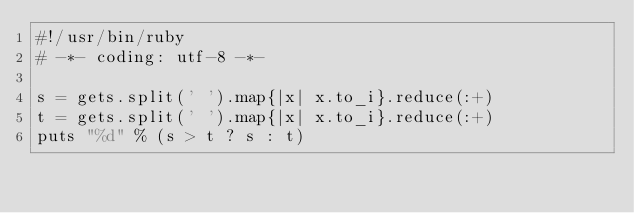<code> <loc_0><loc_0><loc_500><loc_500><_Ruby_>#!/usr/bin/ruby                                                                                                  
# -*- coding: utf-8 -*-                                                                                          

s = gets.split(' ').map{|x| x.to_i}.reduce(:+)
t = gets.split(' ').map{|x| x.to_i}.reduce(:+)
puts "%d" % (s > t ? s : t)</code> 